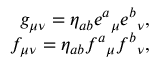Convert formula to latex. <formula><loc_0><loc_0><loc_500><loc_500>\begin{array} { r } { g _ { \mu \nu } = \eta _ { a b } e ^ { a _ { \mu } e ^ { b _ { \nu } , } \\ { f _ { \mu \nu } = \eta _ { a b } f ^ { a _ { \mu } f ^ { b _ { \nu } , } \end{array}</formula> 